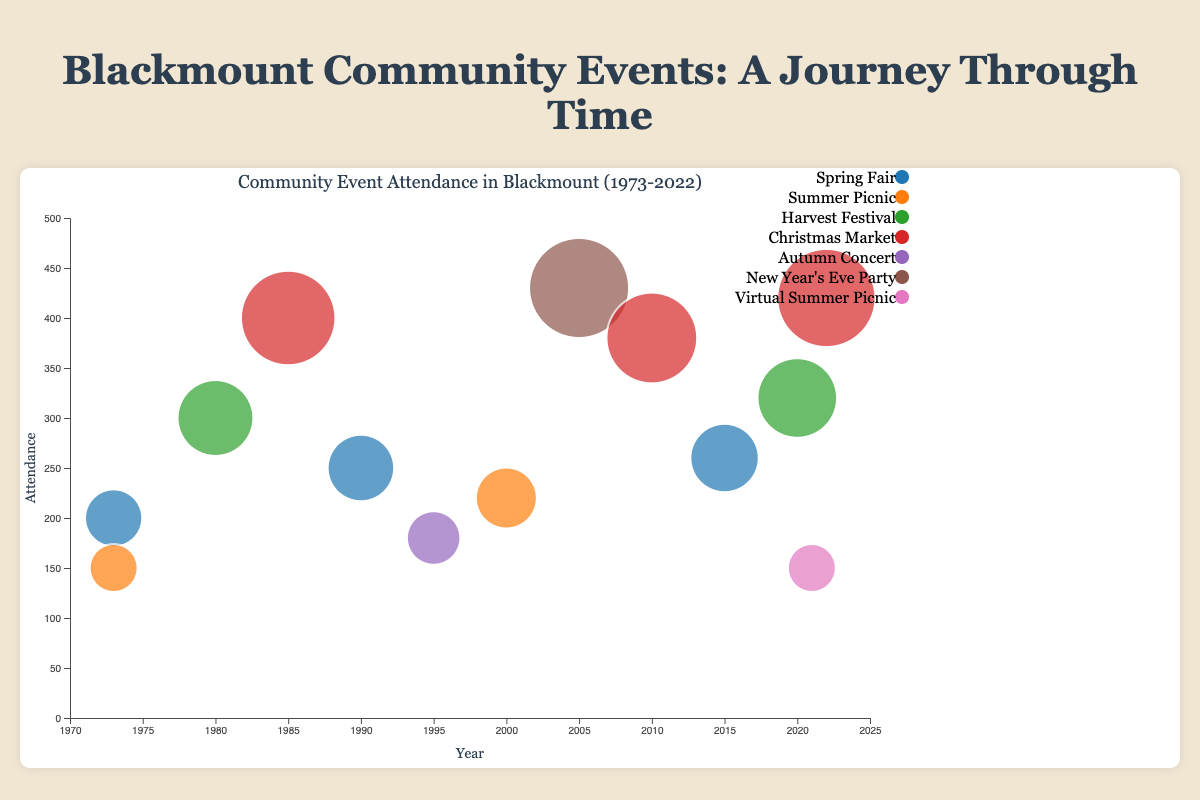What is the title of the bubble chart? The title of the bubble chart is located at the top center and is clearly mentioned as "Community Event Attendance in Blackmount (1973-2022)".
Answer: Community Event Attendance in Blackmount (1973-2022) What is the highest attendance recorded for any event in the chart? By observing the position and size of the largest bubble, the highest attendance recorded is for the "New Year's Eve Party" in 2005 with an attendance of 430.
Answer: 430 Which event appears most frequently over the 50-year period? By looking at the list of legend items and counting the appearances of each event, "Spring Fair" appears the most frequently, occurring in 1973, 1990, 2015.
Answer: Spring Fair How many events had an attendance of over 300? Count the number of events represented by bubbles whose vertical position on the y-axis is above the 300 mark; these events are "Harvest Festival" in 1980, "Christmas Market" in 1985, "New Year's Eve Party" in 2005, "Christmas Market" in 2010, "Harvest Festival" in 2020, and "Christmas Market" in 2022. There are 6 events.
Answer: 6 What is the average attendance of the "Christmas Market" events? Calculate the average by summing up the attendance of the "Christmas Market" events in 1985 (400), 2010 (380), and 2022 (420) and dividing by the number of events. (400 + 380 + 420) / 3 = 1200 / 3
Answer: 400 Which two years had the same attendance for different events? The years 1973 (Spring Fair) and 2021 (Virtual Summer Picnic) both had an attendance of 150.
Answer: 1973 and 2021 Which event had the lowest attendance and in what year? Identify the smallest bubble on the chart and check its label, which is the "Summer Picnic" in 1973 and "Virtual Summer Picnic" in 2021. Both had an attendance of 150.
Answer: Summer Picnic (1973) and Virtual Summer Picnic (2021) How does the attendance trend of "Spring Fair" change over the years? Look at the "Spring Fair" events in the years 1973 (200), 1990 (250), and 2015 (260); the attendance shows a gradual increase over these years.
Answer: Increasing What is the difference in attendance between the highest attended event and the lowest attended event? Identify the highest attendance (430 for New Year's Eve Party in 2005) and the lowest attendance (150 for Summer Picnic in 1973 and Virtual Summer Picnic in 2021) and calculate the difference: 430 - 150 = 280.
Answer: 280 Compare the attendance of the "Harvest Festival" in 1980 with that in 2020. Which one had higher attendance and by how much? The "Harvest Festival" in 1980 had an attendance of 300, while in 2020, it had an attendance of 320. The 2020 event had higher attendance by 20.
Answer: 2020 by 20 